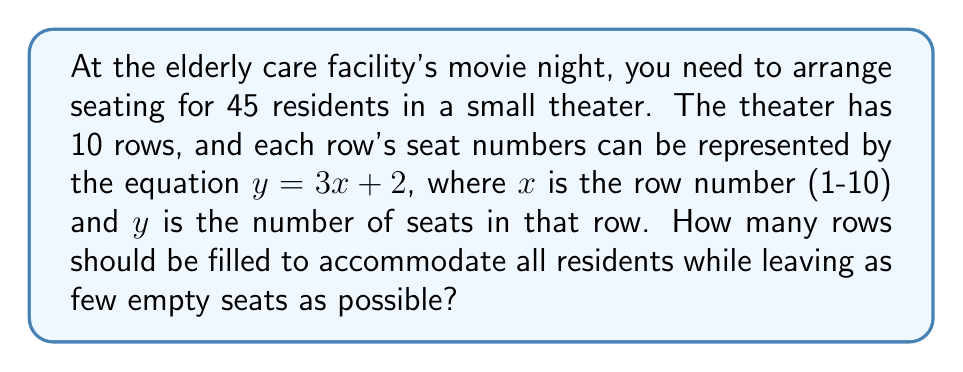Provide a solution to this math problem. Let's approach this step-by-step:

1) First, we need to understand what the equation $y = 3x + 2$ means in this context:
   - $x$ represents the row number (from 1 to 10)
   - $y$ represents the number of seats in each row
   - For example, in row 1 ($x = 1$), there are $y = 3(1) + 2 = 5$ seats

2) Let's calculate the number of seats for each row:
   Row 1: $y = 3(1) + 2 = 5$ seats
   Row 2: $y = 3(2) + 2 = 8$ seats
   Row 3: $y = 3(3) + 2 = 11$ seats
   Row 4: $y = 3(4) + 2 = 14$ seats
   Row 5: $y = 3(5) + 2 = 17$ seats
   Row 6: $y = 3(6) + 2 = 20$ seats
   Row 7: $y = 3(7) + 2 = 23$ seats
   Row 8: $y = 3(8) + 2 = 26$ seats
   Row 9: $y = 3(9) + 2 = 29$ seats
   Row 10: $y = 3(10) + 2 = 32$ seats

3) Now, let's sum up the seats cumulatively:
   1 row: 5 seats
   2 rows: 5 + 8 = 13 seats
   3 rows: 13 + 11 = 24 seats
   4 rows: 24 + 14 = 38 seats
   5 rows: 38 + 17 = 55 seats

4) We need to accommodate 45 residents. From our calculations, we can see that 4 rows (38 seats) are not enough, but 5 rows (55 seats) are more than enough.

5) Therefore, we should use 5 rows. This will accommodate all 45 residents and leave 10 empty seats, which is the smallest number of empty seats possible given the theater's configuration.
Answer: 5 rows 